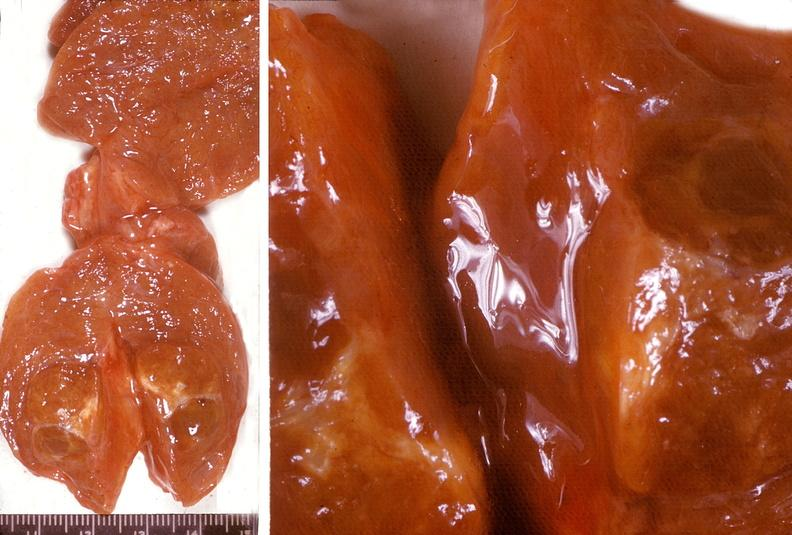s polycystic disease present?
Answer the question using a single word or phrase. No 